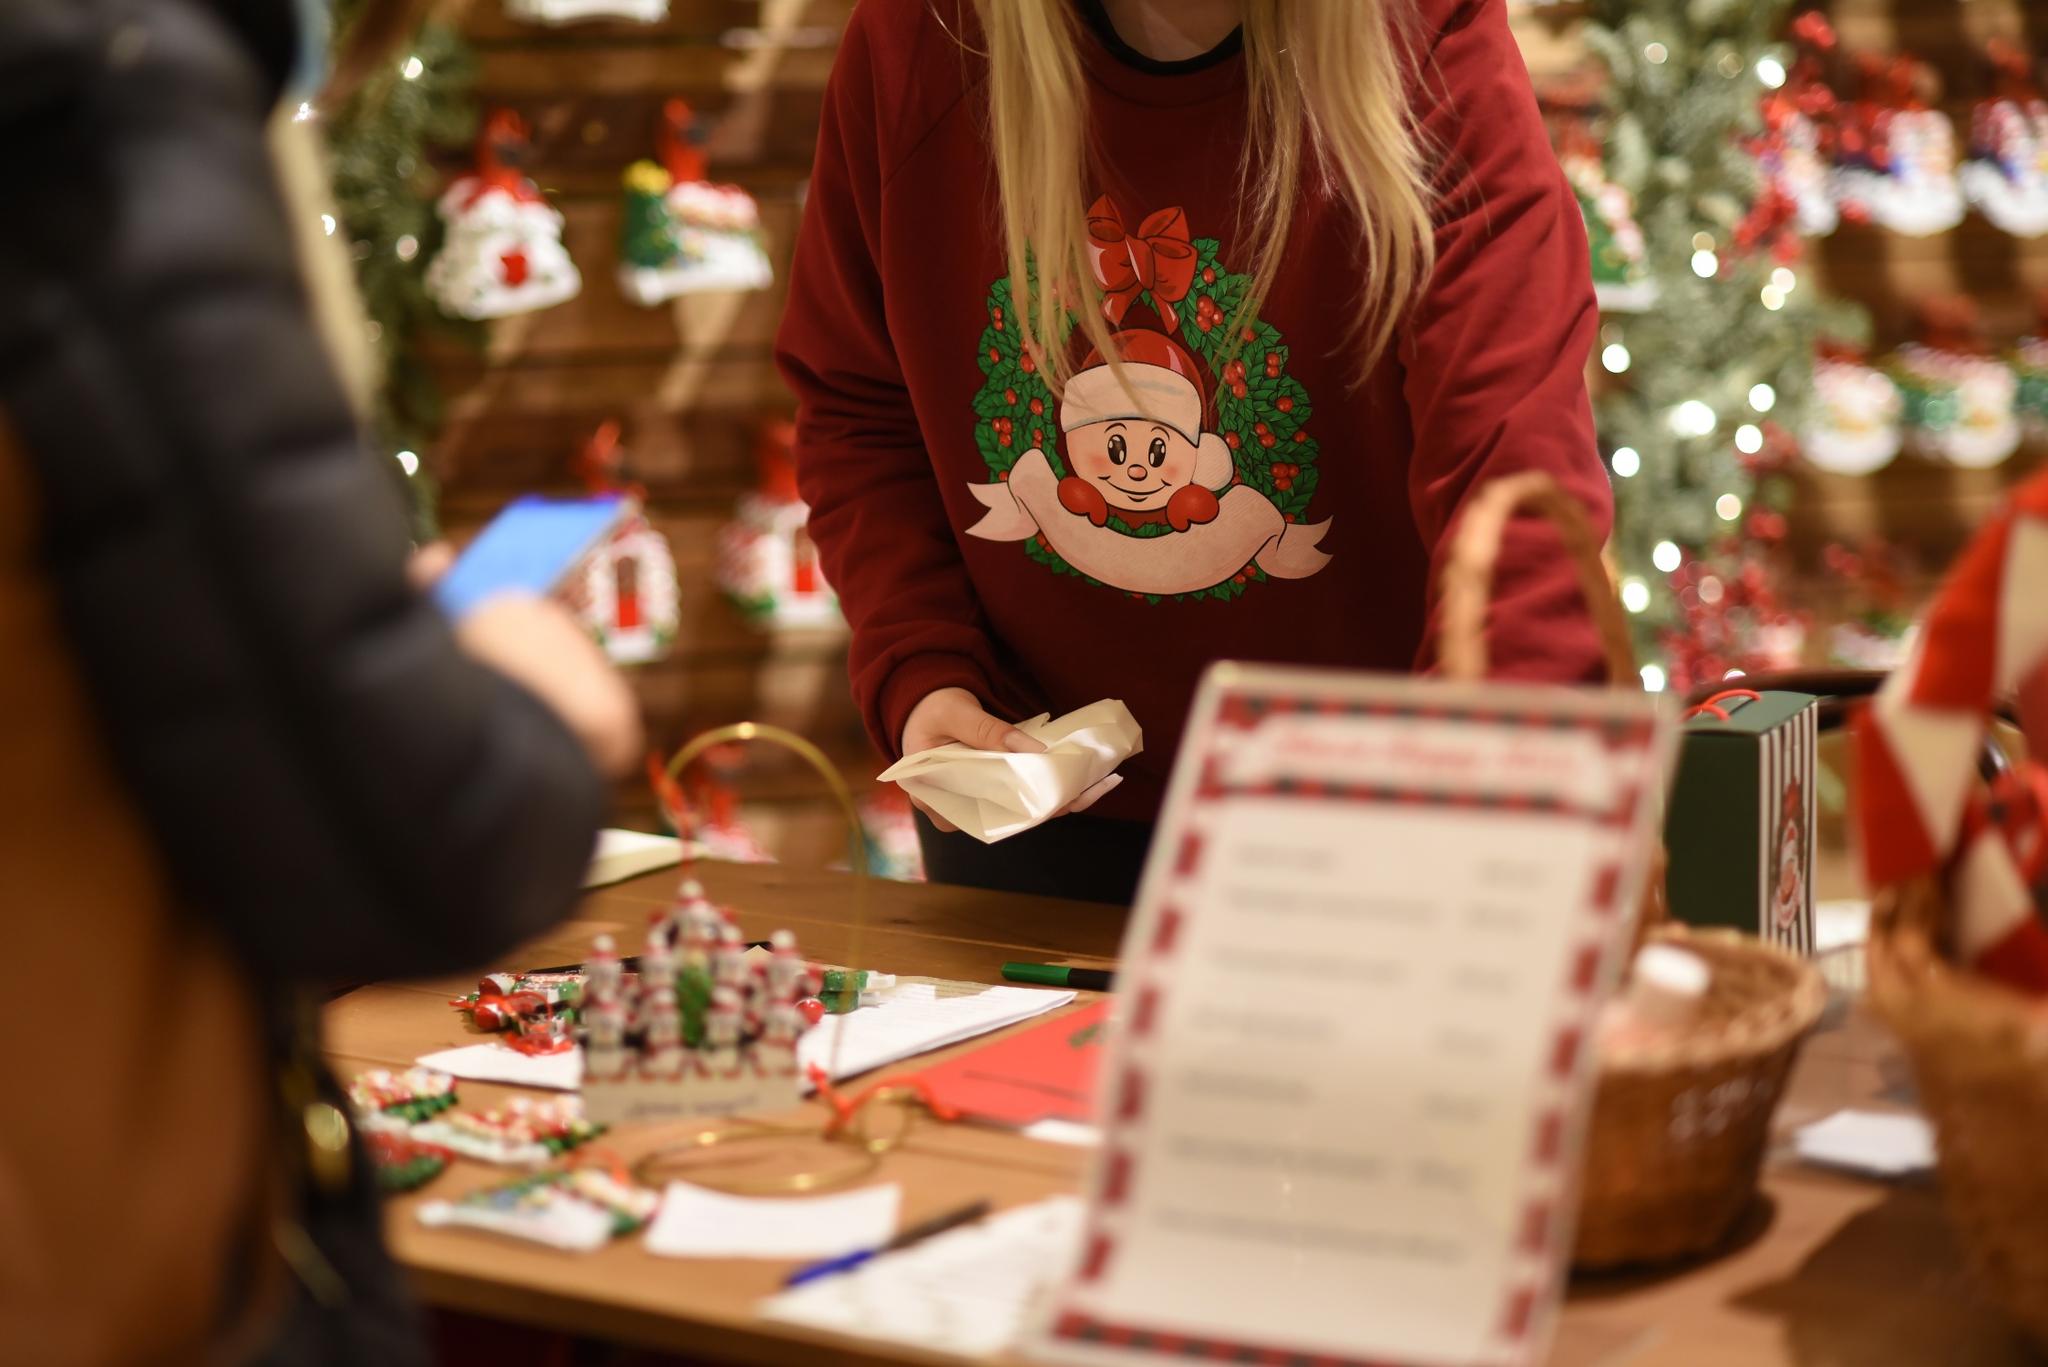What do you think this person's favorite part of their job is? This person’s favorite part of their job is likely the joy and satisfaction of knowing that their efforts contribute to someone’s happiness. They might particularly enjoy the creative process of wrapping each gift, choosing the perfect combination of paper, ribbons, and decorations to make each present unique. Another treasured aspect could be the interactions with customers, hearing their stories, and being a part of their holiday traditions. The warm, appreciative smiles and heartfelt thank-yous from customers receiving beautifully wrapped gifts probably make all the hard work and long hours worthwhile. The person might also cherish the festive atmosphere of the store, surrounded by beautiful decorations and the spirit of giving, which makes the job feel magical and rewarding. 